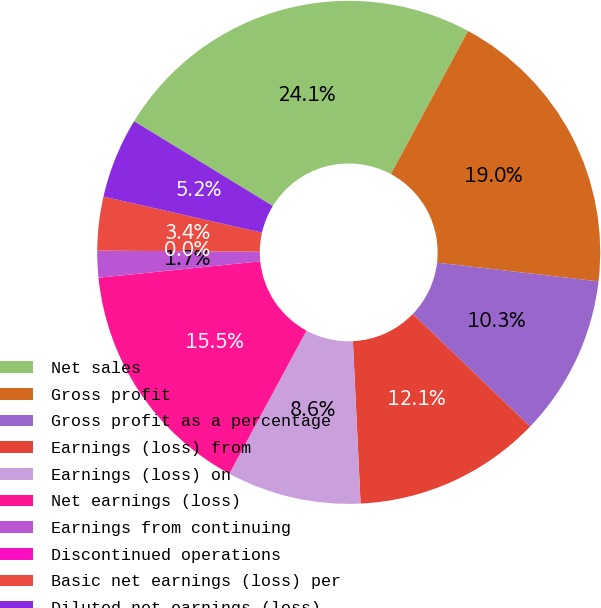Convert chart. <chart><loc_0><loc_0><loc_500><loc_500><pie_chart><fcel>Net sales<fcel>Gross profit<fcel>Gross profit as a percentage<fcel>Earnings (loss) from<fcel>Earnings (loss) on<fcel>Net earnings (loss)<fcel>Earnings from continuing<fcel>Discontinued operations<fcel>Basic net earnings (loss) per<fcel>Diluted net earnings (loss)<nl><fcel>24.14%<fcel>18.97%<fcel>10.34%<fcel>12.07%<fcel>8.62%<fcel>15.52%<fcel>1.72%<fcel>0.0%<fcel>3.45%<fcel>5.17%<nl></chart> 